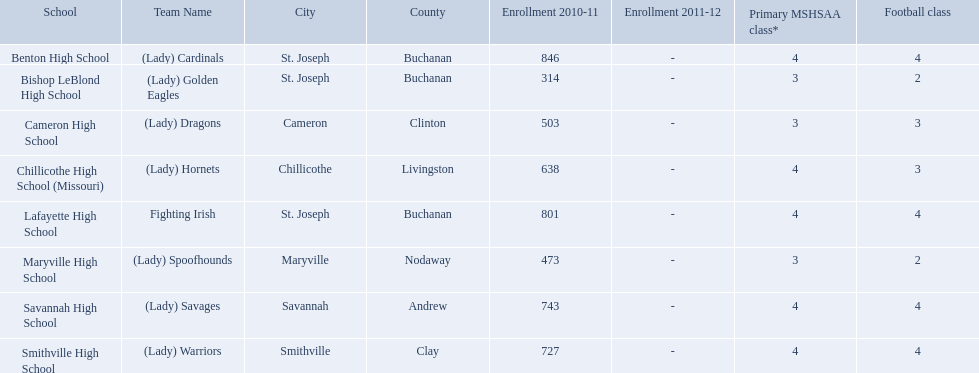What schools are located in st. joseph? Benton High School, Bishop LeBlond High School, Lafayette High School. Which st. joseph schools have more then 800 enrollment  for 2010-11 7 2011-12? Benton High School, Lafayette High School. What is the name of the st. joseph school with 800 or more enrollment's team names is a not a (lady)? Lafayette High School. What are the three schools in the town of st. joseph? St. Joseph, St. Joseph, St. Joseph. Of the three schools in st. joseph which school's team name does not depict a type of animal? Lafayette High School. 